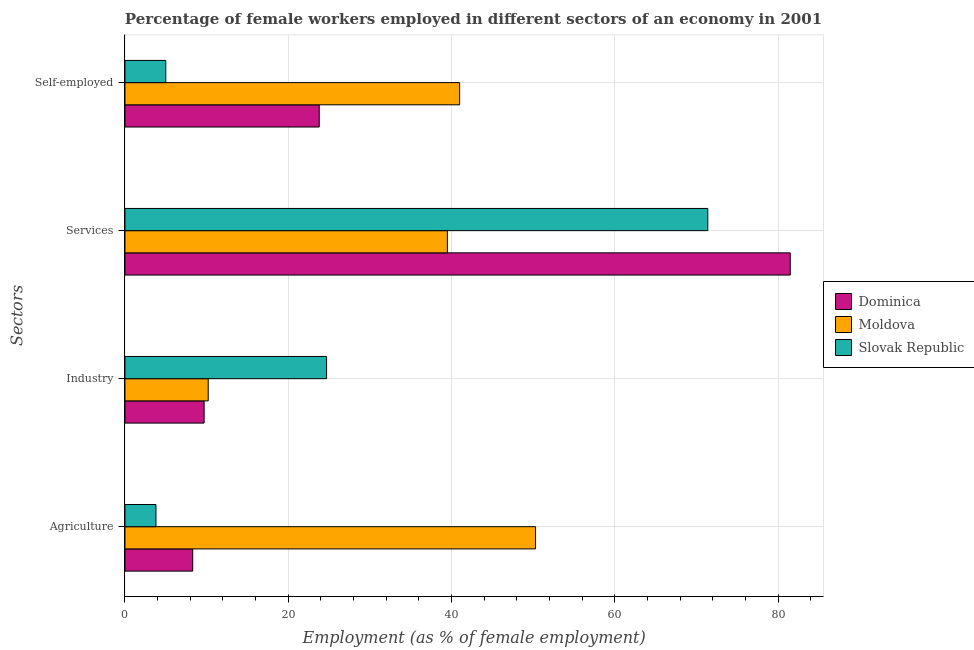How many groups of bars are there?
Offer a very short reply. 4. Are the number of bars on each tick of the Y-axis equal?
Your response must be concise. Yes. How many bars are there on the 2nd tick from the top?
Your answer should be compact. 3. What is the label of the 2nd group of bars from the top?
Make the answer very short. Services. What is the percentage of female workers in services in Dominica?
Keep it short and to the point. 81.5. Across all countries, what is the maximum percentage of female workers in agriculture?
Your answer should be very brief. 50.3. In which country was the percentage of female workers in agriculture maximum?
Your answer should be compact. Moldova. In which country was the percentage of self employed female workers minimum?
Your answer should be compact. Slovak Republic. What is the total percentage of female workers in agriculture in the graph?
Make the answer very short. 62.4. What is the difference between the percentage of female workers in agriculture in Dominica and that in Slovak Republic?
Ensure brevity in your answer.  4.5. What is the difference between the percentage of female workers in agriculture in Dominica and the percentage of female workers in industry in Moldova?
Your answer should be compact. -1.9. What is the average percentage of female workers in services per country?
Offer a very short reply. 64.13. What is the difference between the percentage of female workers in industry and percentage of female workers in agriculture in Dominica?
Offer a very short reply. 1.4. In how many countries, is the percentage of self employed female workers greater than 72 %?
Your response must be concise. 0. What is the ratio of the percentage of self employed female workers in Slovak Republic to that in Dominica?
Provide a short and direct response. 0.21. Is the difference between the percentage of female workers in industry in Moldova and Dominica greater than the difference between the percentage of self employed female workers in Moldova and Dominica?
Keep it short and to the point. No. What is the difference between the highest and the second highest percentage of female workers in services?
Ensure brevity in your answer.  10.1. In how many countries, is the percentage of female workers in industry greater than the average percentage of female workers in industry taken over all countries?
Provide a succinct answer. 1. Is the sum of the percentage of female workers in agriculture in Moldova and Slovak Republic greater than the maximum percentage of female workers in industry across all countries?
Your answer should be compact. Yes. Is it the case that in every country, the sum of the percentage of female workers in industry and percentage of self employed female workers is greater than the sum of percentage of female workers in services and percentage of female workers in agriculture?
Keep it short and to the point. No. What does the 2nd bar from the top in Services represents?
Your answer should be compact. Moldova. What does the 2nd bar from the bottom in Self-employed represents?
Your answer should be compact. Moldova. Is it the case that in every country, the sum of the percentage of female workers in agriculture and percentage of female workers in industry is greater than the percentage of female workers in services?
Make the answer very short. No. What is the difference between two consecutive major ticks on the X-axis?
Give a very brief answer. 20. Are the values on the major ticks of X-axis written in scientific E-notation?
Give a very brief answer. No. Where does the legend appear in the graph?
Give a very brief answer. Center right. How many legend labels are there?
Give a very brief answer. 3. How are the legend labels stacked?
Keep it short and to the point. Vertical. What is the title of the graph?
Provide a short and direct response. Percentage of female workers employed in different sectors of an economy in 2001. Does "Armenia" appear as one of the legend labels in the graph?
Provide a short and direct response. No. What is the label or title of the X-axis?
Provide a succinct answer. Employment (as % of female employment). What is the label or title of the Y-axis?
Your answer should be compact. Sectors. What is the Employment (as % of female employment) in Dominica in Agriculture?
Make the answer very short. 8.3. What is the Employment (as % of female employment) in Moldova in Agriculture?
Your response must be concise. 50.3. What is the Employment (as % of female employment) in Slovak Republic in Agriculture?
Provide a succinct answer. 3.8. What is the Employment (as % of female employment) in Dominica in Industry?
Offer a very short reply. 9.7. What is the Employment (as % of female employment) in Moldova in Industry?
Provide a succinct answer. 10.2. What is the Employment (as % of female employment) of Slovak Republic in Industry?
Your answer should be very brief. 24.7. What is the Employment (as % of female employment) in Dominica in Services?
Ensure brevity in your answer.  81.5. What is the Employment (as % of female employment) of Moldova in Services?
Offer a terse response. 39.5. What is the Employment (as % of female employment) of Slovak Republic in Services?
Offer a very short reply. 71.4. What is the Employment (as % of female employment) in Dominica in Self-employed?
Your response must be concise. 23.8. What is the Employment (as % of female employment) in Moldova in Self-employed?
Ensure brevity in your answer.  41. What is the Employment (as % of female employment) in Slovak Republic in Self-employed?
Keep it short and to the point. 5. Across all Sectors, what is the maximum Employment (as % of female employment) in Dominica?
Your answer should be very brief. 81.5. Across all Sectors, what is the maximum Employment (as % of female employment) in Moldova?
Offer a very short reply. 50.3. Across all Sectors, what is the maximum Employment (as % of female employment) in Slovak Republic?
Your answer should be compact. 71.4. Across all Sectors, what is the minimum Employment (as % of female employment) of Dominica?
Your answer should be compact. 8.3. Across all Sectors, what is the minimum Employment (as % of female employment) of Moldova?
Your response must be concise. 10.2. Across all Sectors, what is the minimum Employment (as % of female employment) of Slovak Republic?
Your answer should be very brief. 3.8. What is the total Employment (as % of female employment) of Dominica in the graph?
Provide a short and direct response. 123.3. What is the total Employment (as % of female employment) in Moldova in the graph?
Provide a short and direct response. 141. What is the total Employment (as % of female employment) in Slovak Republic in the graph?
Offer a very short reply. 104.9. What is the difference between the Employment (as % of female employment) in Dominica in Agriculture and that in Industry?
Your response must be concise. -1.4. What is the difference between the Employment (as % of female employment) of Moldova in Agriculture and that in Industry?
Ensure brevity in your answer.  40.1. What is the difference between the Employment (as % of female employment) in Slovak Republic in Agriculture and that in Industry?
Your response must be concise. -20.9. What is the difference between the Employment (as % of female employment) of Dominica in Agriculture and that in Services?
Provide a succinct answer. -73.2. What is the difference between the Employment (as % of female employment) of Moldova in Agriculture and that in Services?
Your answer should be compact. 10.8. What is the difference between the Employment (as % of female employment) of Slovak Republic in Agriculture and that in Services?
Your answer should be very brief. -67.6. What is the difference between the Employment (as % of female employment) of Dominica in Agriculture and that in Self-employed?
Ensure brevity in your answer.  -15.5. What is the difference between the Employment (as % of female employment) of Moldova in Agriculture and that in Self-employed?
Your answer should be very brief. 9.3. What is the difference between the Employment (as % of female employment) in Slovak Republic in Agriculture and that in Self-employed?
Your answer should be compact. -1.2. What is the difference between the Employment (as % of female employment) in Dominica in Industry and that in Services?
Offer a very short reply. -71.8. What is the difference between the Employment (as % of female employment) of Moldova in Industry and that in Services?
Give a very brief answer. -29.3. What is the difference between the Employment (as % of female employment) in Slovak Republic in Industry and that in Services?
Offer a very short reply. -46.7. What is the difference between the Employment (as % of female employment) of Dominica in Industry and that in Self-employed?
Make the answer very short. -14.1. What is the difference between the Employment (as % of female employment) in Moldova in Industry and that in Self-employed?
Your answer should be compact. -30.8. What is the difference between the Employment (as % of female employment) of Slovak Republic in Industry and that in Self-employed?
Your answer should be compact. 19.7. What is the difference between the Employment (as % of female employment) of Dominica in Services and that in Self-employed?
Make the answer very short. 57.7. What is the difference between the Employment (as % of female employment) in Moldova in Services and that in Self-employed?
Provide a short and direct response. -1.5. What is the difference between the Employment (as % of female employment) of Slovak Republic in Services and that in Self-employed?
Keep it short and to the point. 66.4. What is the difference between the Employment (as % of female employment) of Dominica in Agriculture and the Employment (as % of female employment) of Slovak Republic in Industry?
Offer a very short reply. -16.4. What is the difference between the Employment (as % of female employment) of Moldova in Agriculture and the Employment (as % of female employment) of Slovak Republic in Industry?
Make the answer very short. 25.6. What is the difference between the Employment (as % of female employment) of Dominica in Agriculture and the Employment (as % of female employment) of Moldova in Services?
Give a very brief answer. -31.2. What is the difference between the Employment (as % of female employment) of Dominica in Agriculture and the Employment (as % of female employment) of Slovak Republic in Services?
Keep it short and to the point. -63.1. What is the difference between the Employment (as % of female employment) in Moldova in Agriculture and the Employment (as % of female employment) in Slovak Republic in Services?
Offer a very short reply. -21.1. What is the difference between the Employment (as % of female employment) of Dominica in Agriculture and the Employment (as % of female employment) of Moldova in Self-employed?
Your answer should be compact. -32.7. What is the difference between the Employment (as % of female employment) of Moldova in Agriculture and the Employment (as % of female employment) of Slovak Republic in Self-employed?
Ensure brevity in your answer.  45.3. What is the difference between the Employment (as % of female employment) of Dominica in Industry and the Employment (as % of female employment) of Moldova in Services?
Your answer should be compact. -29.8. What is the difference between the Employment (as % of female employment) of Dominica in Industry and the Employment (as % of female employment) of Slovak Republic in Services?
Keep it short and to the point. -61.7. What is the difference between the Employment (as % of female employment) in Moldova in Industry and the Employment (as % of female employment) in Slovak Republic in Services?
Give a very brief answer. -61.2. What is the difference between the Employment (as % of female employment) of Dominica in Industry and the Employment (as % of female employment) of Moldova in Self-employed?
Ensure brevity in your answer.  -31.3. What is the difference between the Employment (as % of female employment) of Dominica in Services and the Employment (as % of female employment) of Moldova in Self-employed?
Your answer should be very brief. 40.5. What is the difference between the Employment (as % of female employment) in Dominica in Services and the Employment (as % of female employment) in Slovak Republic in Self-employed?
Offer a terse response. 76.5. What is the difference between the Employment (as % of female employment) of Moldova in Services and the Employment (as % of female employment) of Slovak Republic in Self-employed?
Make the answer very short. 34.5. What is the average Employment (as % of female employment) of Dominica per Sectors?
Your answer should be very brief. 30.82. What is the average Employment (as % of female employment) in Moldova per Sectors?
Give a very brief answer. 35.25. What is the average Employment (as % of female employment) in Slovak Republic per Sectors?
Ensure brevity in your answer.  26.23. What is the difference between the Employment (as % of female employment) in Dominica and Employment (as % of female employment) in Moldova in Agriculture?
Give a very brief answer. -42. What is the difference between the Employment (as % of female employment) of Dominica and Employment (as % of female employment) of Slovak Republic in Agriculture?
Offer a very short reply. 4.5. What is the difference between the Employment (as % of female employment) in Moldova and Employment (as % of female employment) in Slovak Republic in Agriculture?
Offer a very short reply. 46.5. What is the difference between the Employment (as % of female employment) in Dominica and Employment (as % of female employment) in Moldova in Industry?
Give a very brief answer. -0.5. What is the difference between the Employment (as % of female employment) in Dominica and Employment (as % of female employment) in Slovak Republic in Services?
Offer a terse response. 10.1. What is the difference between the Employment (as % of female employment) of Moldova and Employment (as % of female employment) of Slovak Republic in Services?
Your answer should be very brief. -31.9. What is the difference between the Employment (as % of female employment) in Dominica and Employment (as % of female employment) in Moldova in Self-employed?
Your answer should be compact. -17.2. What is the difference between the Employment (as % of female employment) in Moldova and Employment (as % of female employment) in Slovak Republic in Self-employed?
Make the answer very short. 36. What is the ratio of the Employment (as % of female employment) of Dominica in Agriculture to that in Industry?
Your answer should be very brief. 0.86. What is the ratio of the Employment (as % of female employment) in Moldova in Agriculture to that in Industry?
Provide a succinct answer. 4.93. What is the ratio of the Employment (as % of female employment) in Slovak Republic in Agriculture to that in Industry?
Your answer should be very brief. 0.15. What is the ratio of the Employment (as % of female employment) of Dominica in Agriculture to that in Services?
Offer a very short reply. 0.1. What is the ratio of the Employment (as % of female employment) of Moldova in Agriculture to that in Services?
Offer a terse response. 1.27. What is the ratio of the Employment (as % of female employment) in Slovak Republic in Agriculture to that in Services?
Provide a succinct answer. 0.05. What is the ratio of the Employment (as % of female employment) in Dominica in Agriculture to that in Self-employed?
Offer a very short reply. 0.35. What is the ratio of the Employment (as % of female employment) of Moldova in Agriculture to that in Self-employed?
Your response must be concise. 1.23. What is the ratio of the Employment (as % of female employment) in Slovak Republic in Agriculture to that in Self-employed?
Your answer should be compact. 0.76. What is the ratio of the Employment (as % of female employment) of Dominica in Industry to that in Services?
Your response must be concise. 0.12. What is the ratio of the Employment (as % of female employment) in Moldova in Industry to that in Services?
Offer a terse response. 0.26. What is the ratio of the Employment (as % of female employment) of Slovak Republic in Industry to that in Services?
Keep it short and to the point. 0.35. What is the ratio of the Employment (as % of female employment) in Dominica in Industry to that in Self-employed?
Keep it short and to the point. 0.41. What is the ratio of the Employment (as % of female employment) of Moldova in Industry to that in Self-employed?
Offer a terse response. 0.25. What is the ratio of the Employment (as % of female employment) of Slovak Republic in Industry to that in Self-employed?
Keep it short and to the point. 4.94. What is the ratio of the Employment (as % of female employment) in Dominica in Services to that in Self-employed?
Provide a short and direct response. 3.42. What is the ratio of the Employment (as % of female employment) of Moldova in Services to that in Self-employed?
Provide a succinct answer. 0.96. What is the ratio of the Employment (as % of female employment) of Slovak Republic in Services to that in Self-employed?
Offer a terse response. 14.28. What is the difference between the highest and the second highest Employment (as % of female employment) in Dominica?
Your answer should be very brief. 57.7. What is the difference between the highest and the second highest Employment (as % of female employment) in Slovak Republic?
Your answer should be compact. 46.7. What is the difference between the highest and the lowest Employment (as % of female employment) of Dominica?
Offer a very short reply. 73.2. What is the difference between the highest and the lowest Employment (as % of female employment) in Moldova?
Make the answer very short. 40.1. What is the difference between the highest and the lowest Employment (as % of female employment) in Slovak Republic?
Give a very brief answer. 67.6. 